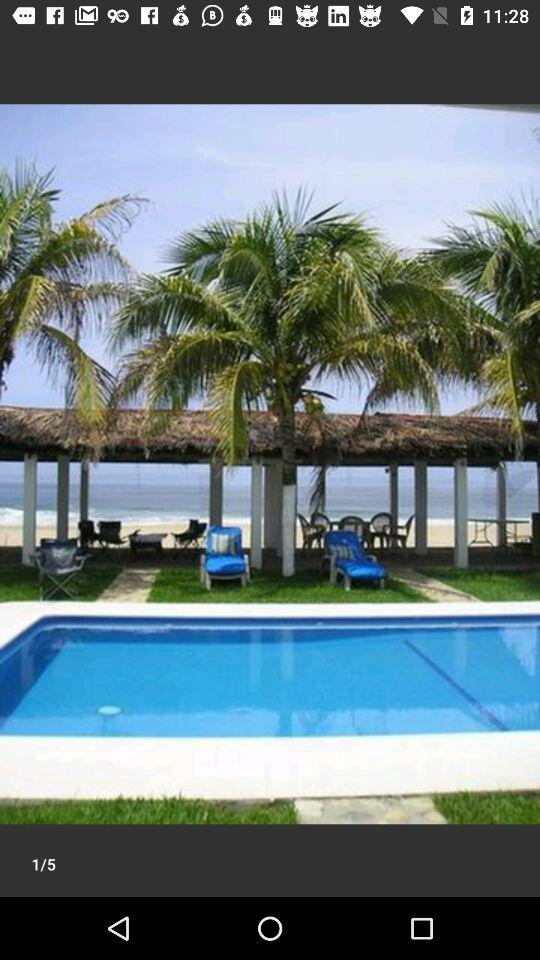Which image number is the person currently on? The person is currently on the first image number. 